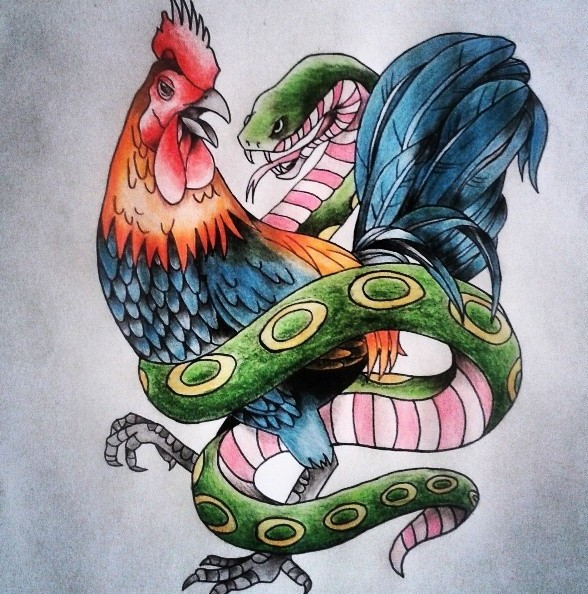Can you explain the potential mythological significance of the rooster and the snake intertwined in this artwork? In many mythologies, both the rooster and snake hold significant roles. The rooster is often associated with the sun god due to its crowing at dawn, symbolizing the victory of light over darkness. The snake, conversely, is frequently linked to chthonic forces, embodying the earth and the underworld. Their intertwining could signify the union or struggle between celestial and terrestrial realms, or the interaction between the forces of light and darkness. This artwork might be exploring these profound themes, presenting a narrative where both animals are in a perpetual dance of balance and conflict. 